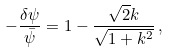Convert formula to latex. <formula><loc_0><loc_0><loc_500><loc_500>- \frac { \delta \psi } { \bar { \psi } } = 1 - \frac { \sqrt { 2 } k } { \sqrt { 1 + k ^ { 2 } } } \, ,</formula> 